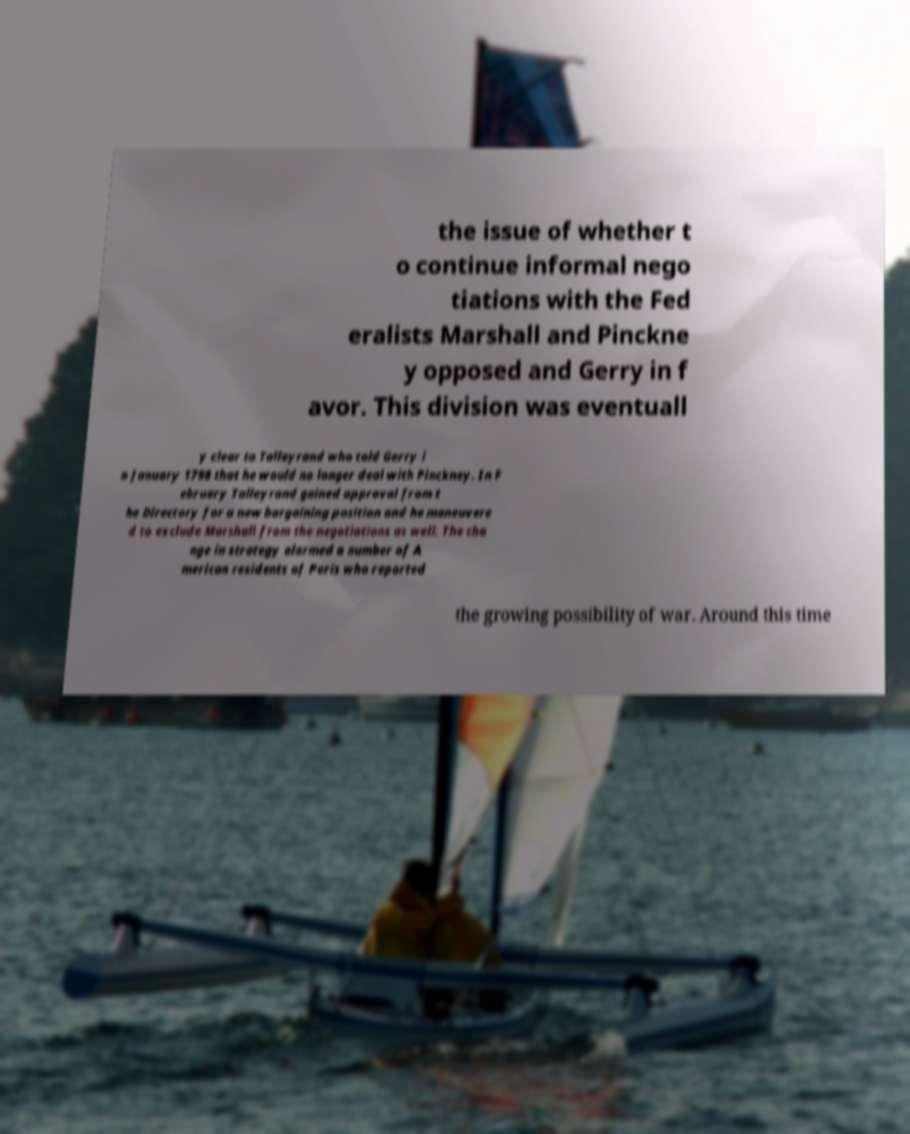For documentation purposes, I need the text within this image transcribed. Could you provide that? the issue of whether t o continue informal nego tiations with the Fed eralists Marshall and Pinckne y opposed and Gerry in f avor. This division was eventuall y clear to Talleyrand who told Gerry i n January 1798 that he would no longer deal with Pinckney. In F ebruary Talleyrand gained approval from t he Directory for a new bargaining position and he maneuvere d to exclude Marshall from the negotiations as well. The cha nge in strategy alarmed a number of A merican residents of Paris who reported the growing possibility of war. Around this time 